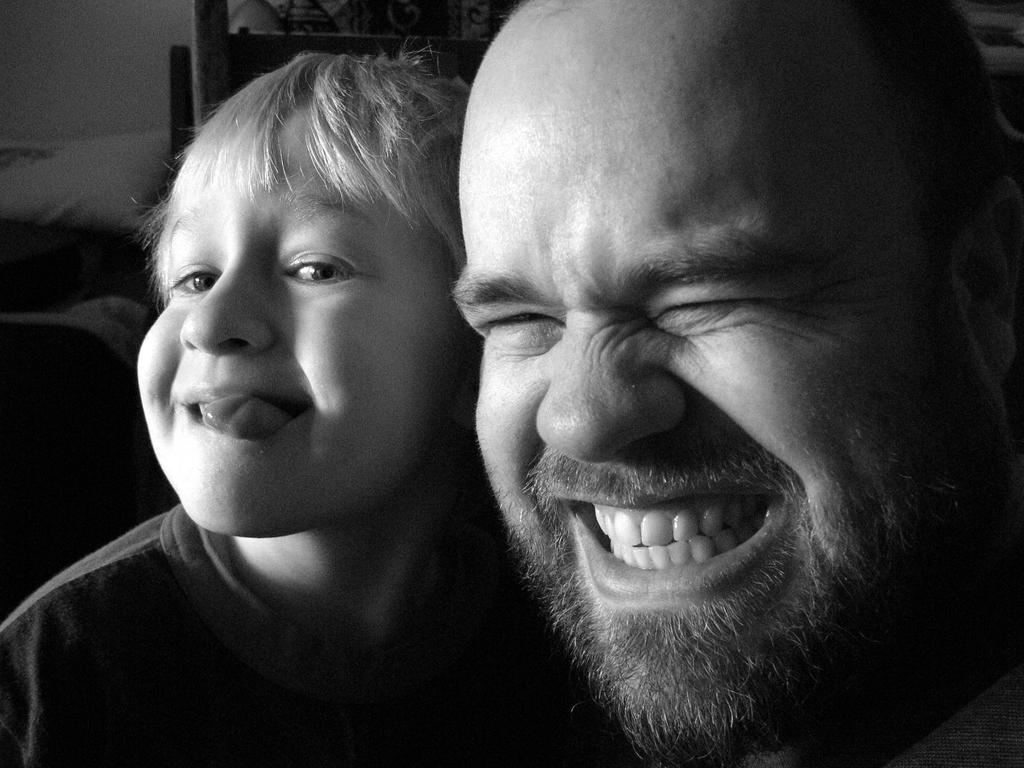Please provide a concise description of this image. This is a black and white image of a man and a child. Man is smiling and the child is keeping the tongue outside. 